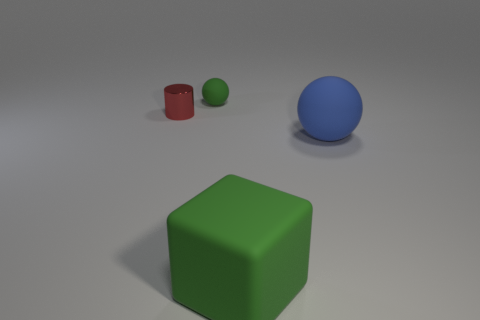Does the blue rubber thing have the same size as the red thing?
Keep it short and to the point. No. There is a big blue thing that is the same shape as the small green rubber thing; what is it made of?
Provide a short and direct response. Rubber. Are there any other things that have the same material as the green ball?
Keep it short and to the point. Yes. What number of purple things are either shiny cubes or blocks?
Your response must be concise. 0. What is the green thing that is in front of the big blue object made of?
Offer a very short reply. Rubber. Are there more brown matte balls than small green objects?
Offer a terse response. No. There is a tiny thing on the left side of the tiny green object; is its shape the same as the tiny green rubber thing?
Make the answer very short. No. What number of green rubber objects are both in front of the tiny green matte object and to the left of the big green cube?
Your answer should be compact. 0. What number of other small metal things have the same shape as the metallic object?
Keep it short and to the point. 0. There is a matte object that is in front of the sphere that is on the right side of the small green rubber thing; what is its color?
Your answer should be very brief. Green. 